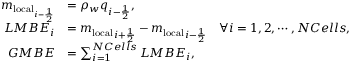Convert formula to latex. <formula><loc_0><loc_0><loc_500><loc_500>\begin{array} { r l } { m _ { l o c a l _ { i - \frac { 1 } { 2 } } } } & { = \rho _ { w } q _ { i - \frac { 1 } { 2 } } , } \\ { L M B E _ { i } } & { = { m _ { l o c a l } } _ { i + \frac { 1 } { 2 } } - { m _ { l o c a l } } _ { i - \frac { 1 } { 2 } } \quad \forall i = 1 , 2 , \cdots , N C e l l s , } \\ { G M B E } & { = \sum _ { i = 1 } ^ { N C e l l s } L M B E _ { i } , } \end{array}</formula> 